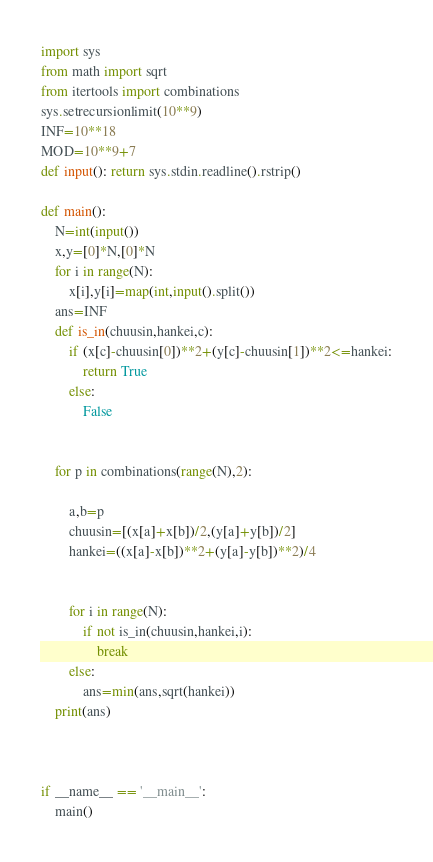Convert code to text. <code><loc_0><loc_0><loc_500><loc_500><_Python_>import sys
from math import sqrt
from itertools import combinations
sys.setrecursionlimit(10**9)
INF=10**18
MOD=10**9+7
def input(): return sys.stdin.readline().rstrip()

def main():
    N=int(input())
    x,y=[0]*N,[0]*N
    for i in range(N):
        x[i],y[i]=map(int,input().split())
    ans=INF
    def is_in(chuusin,hankei,c):
        if (x[c]-chuusin[0])**2+(y[c]-chuusin[1])**2<=hankei:
            return True
        else:
            False
    
    
    for p in combinations(range(N),2):
        
        a,b=p
        chuusin=[(x[a]+x[b])/2,(y[a]+y[b])/2]
        hankei=((x[a]-x[b])**2+(y[a]-y[b])**2)/4
        
        
        for i in range(N):
            if not is_in(chuusin,hankei,i):
                break
        else:
            ans=min(ans,sqrt(hankei))
    print(ans)
        
    

if __name__ == '__main__':
    main()
</code> 